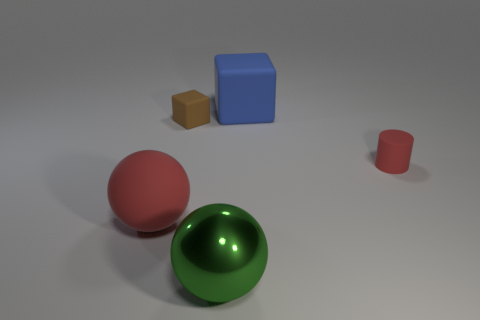Add 5 big green spheres. How many objects exist? 10 Subtract all blocks. How many objects are left? 3 Add 4 small red rubber cubes. How many small red rubber cubes exist? 4 Subtract 0 gray spheres. How many objects are left? 5 Subtract all metallic balls. Subtract all green metallic balls. How many objects are left? 3 Add 4 red rubber cylinders. How many red rubber cylinders are left? 5 